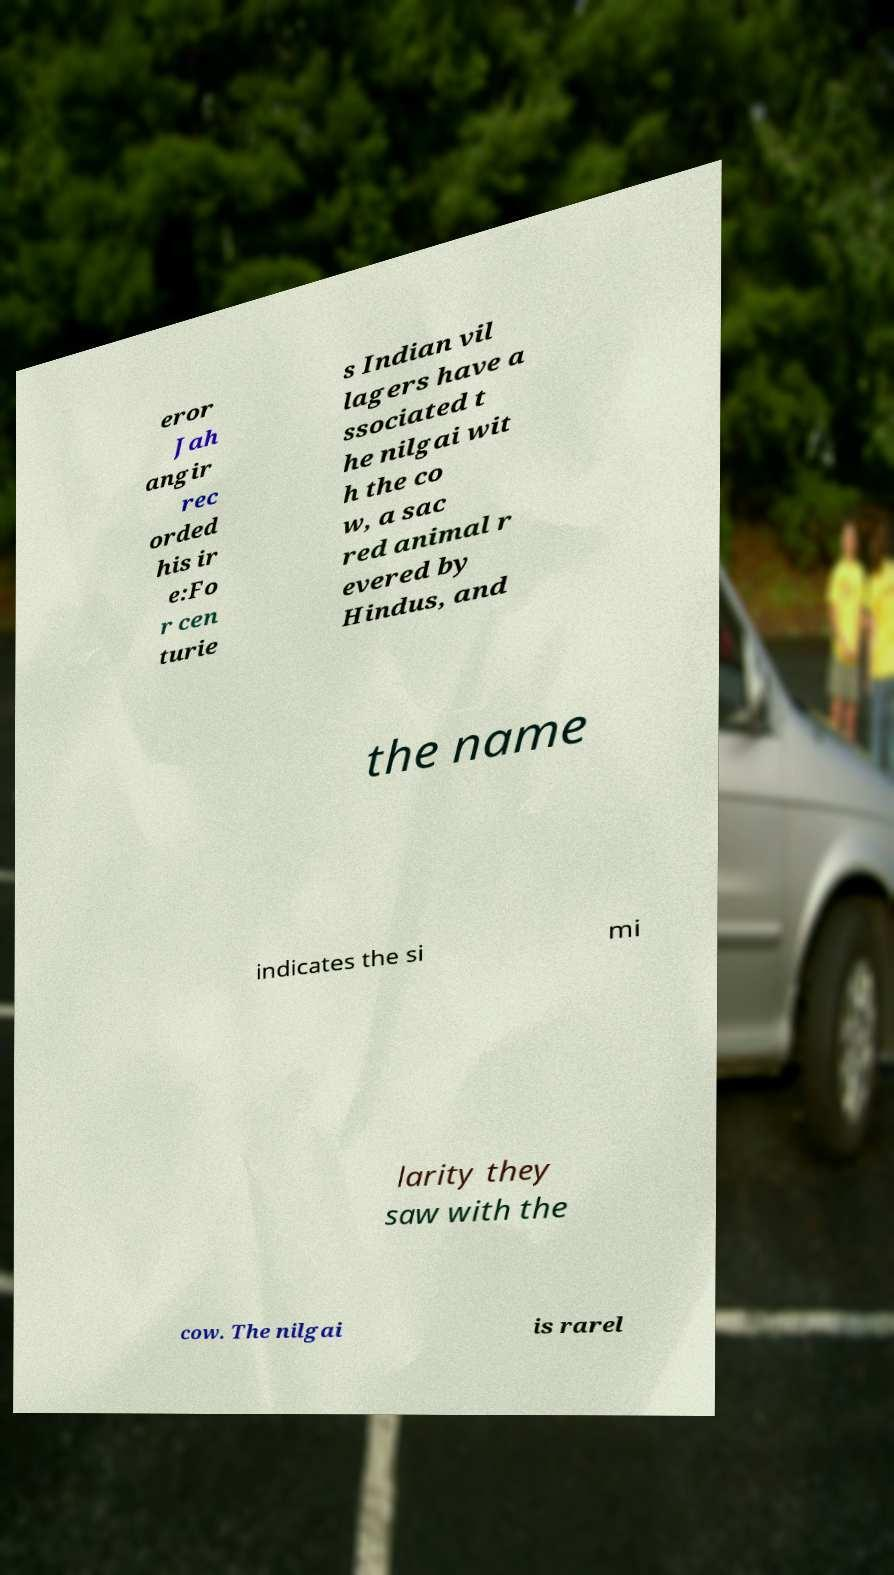Could you assist in decoding the text presented in this image and type it out clearly? eror Jah angir rec orded his ir e:Fo r cen turie s Indian vil lagers have a ssociated t he nilgai wit h the co w, a sac red animal r evered by Hindus, and the name indicates the si mi larity they saw with the cow. The nilgai is rarel 